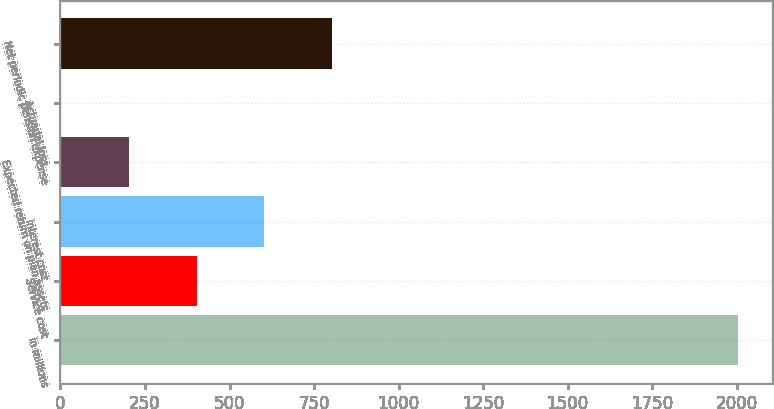<chart> <loc_0><loc_0><loc_500><loc_500><bar_chart><fcel>In millions<fcel>Service cost<fcel>Interest cost<fcel>Expected return on plan assets<fcel>Actuarial loss<fcel>Net periodic pension expense<nl><fcel>2005<fcel>402.6<fcel>602.9<fcel>202.3<fcel>2<fcel>803.2<nl></chart> 